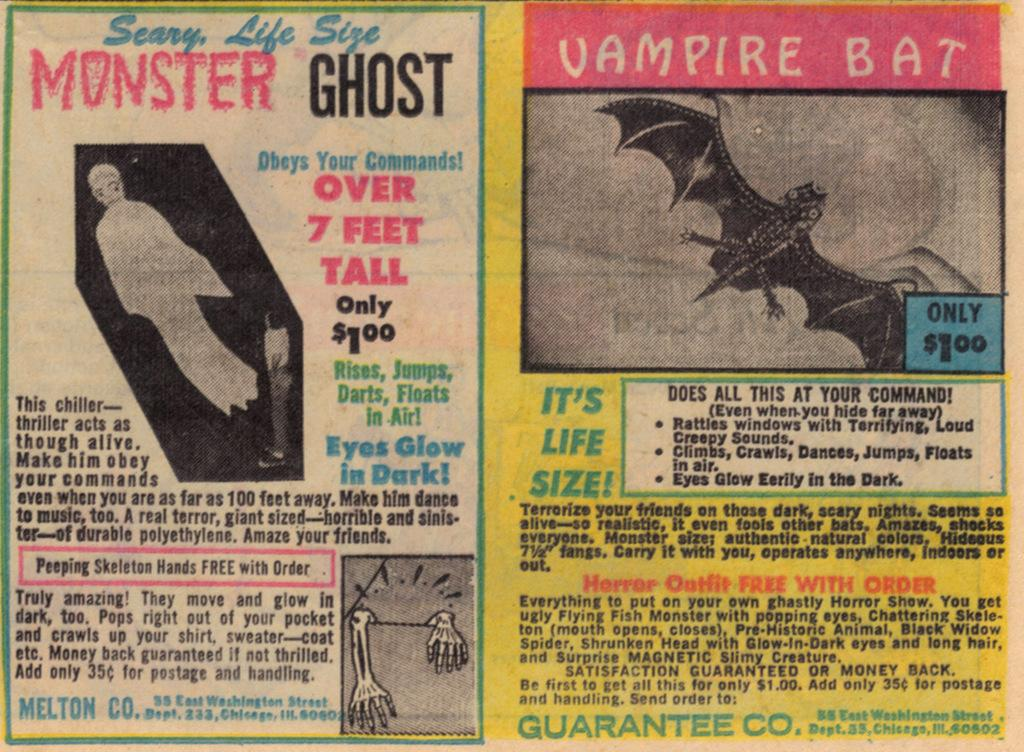<image>
Write a terse but informative summary of the picture. old comic book ads for monster ghost and vampire bat, they are $1 each plus 35 cents for postage and handling 